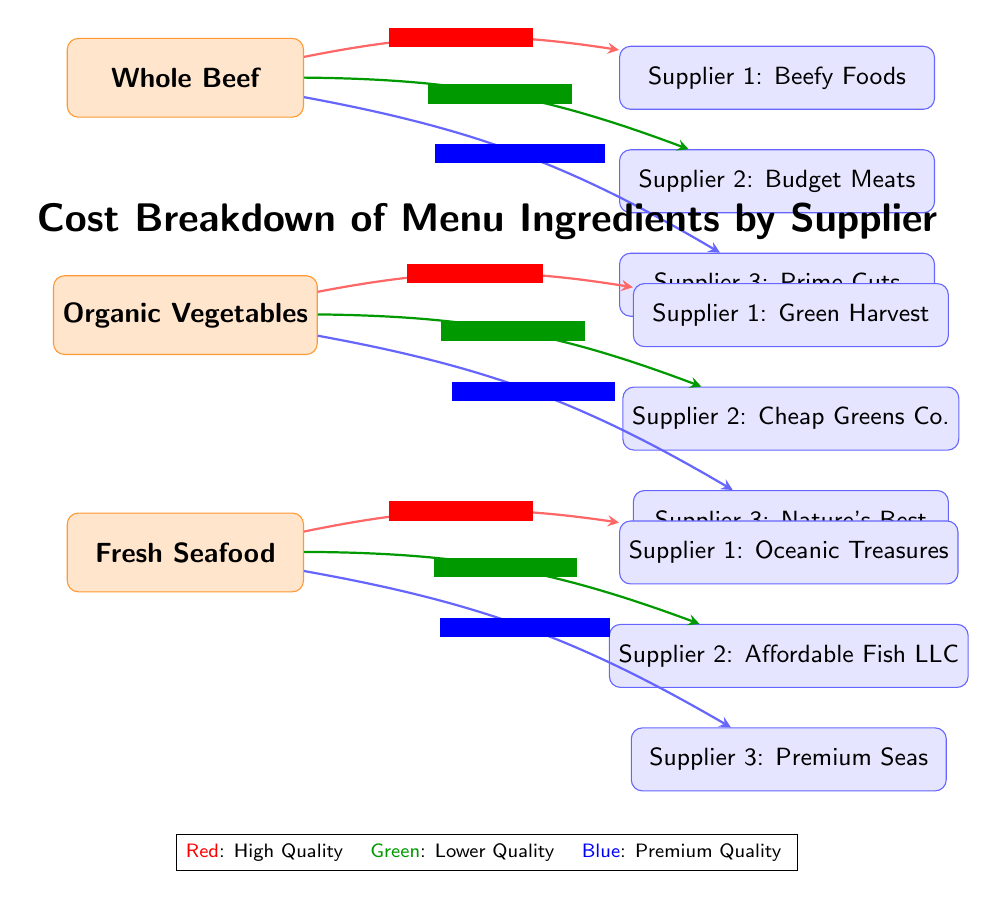What is the cost of high-quality beef from Supplier 1? The diagram shows an arrow from "Whole Beef" to "Supplier 1: Beefy Foods" labeled with "High Quality - $10/kg," indicating this is the cost for that supplier's high-quality beef.
Answer: $10/kg Which supplier offers the lowest-cost vegetables? The diagram indicates an arrow from "Organic Vegetables" to "Supplier 2: Cheap Greens Co." labeled with "Lower Quality - $3/kg," showing that this supplier has the lowest cost for vegetables.
Answer: Supplier 2: Cheap Greens Co How many suppliers provide fresh seafood? The diagram lists three suppliers connected to "Fresh Seafood," which are "Supplier 1: Oceanic Treasures," "Supplier 2: Affordable Fish LLC," and "Supplier 3: Premium Seas." Counting these gives a total of three suppliers.
Answer: 3 What is the cost difference between the high-quality and lower-quality seafood? From "Fresh Seafood," the high-quality option is connected to "Supplier 1: Oceanic Treasures" for $12/kg, while the lower-quality seafood is connected to "Supplier 2: Affordable Fish LLC" for $9/kg. The difference is calculated as $12 - $9 = $3.
Answer: $3 Which ingredient has the cheapest option from its suppliers? Examining the suppliers for each ingredient, "Organic Vegetables" has a lower-quality option from "Supplier 2: Cheap Greens Co." at $3/kg, which is less than any option for Whole Beef or Fresh Seafood.
Answer: Organic Vegetables What is the highest price for beef among the suppliers? The diagram shows "Supplier 3: Prime Cuts" has a premium quality beef priced at $15/kg, which is the highest price compared to other suppliers for beef.
Answer: $15/kg Which ingredient has the highest premium quality cost? Looking at the premium quality costs in the diagram, Fresh Seafood from "Supplier 3: Premium Seas" has a cost of $18/kg, which is higher than any other ingredient's premium quality cost.
Answer: $18/kg How many different quality levels are there for vegetables? The diagram shows three arrows leading from "Organic Vegetables," indicating three distinct quality levels: High Quality, Lower Quality, and Premium Quality.
Answer: 3 